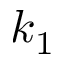<formula> <loc_0><loc_0><loc_500><loc_500>k _ { 1 }</formula> 